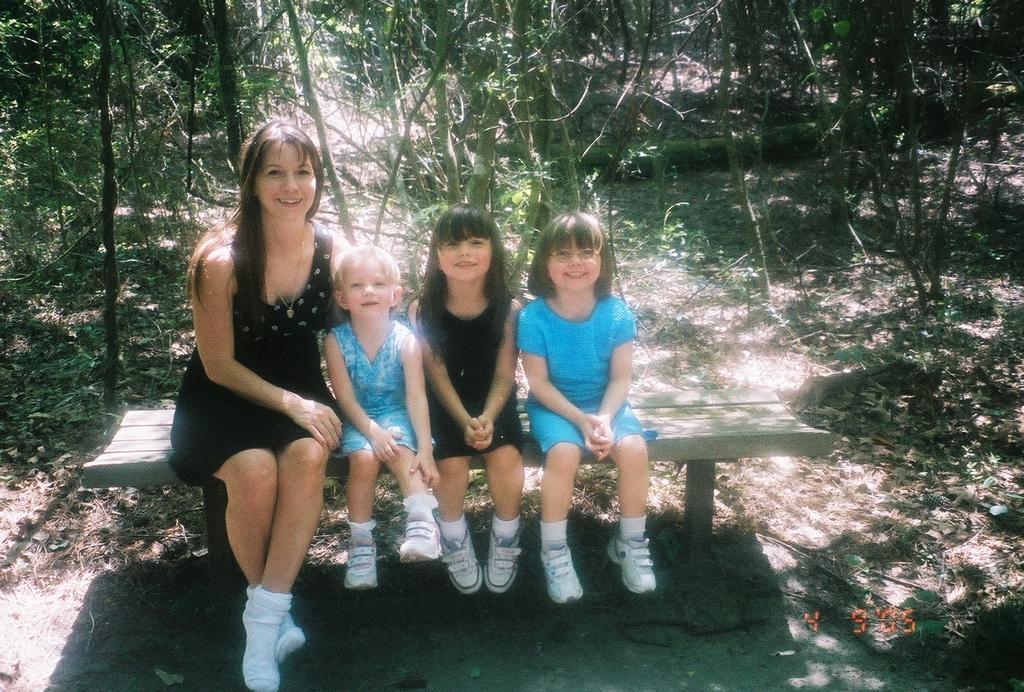Describe this image in one or two sentences. In this image I can see a bench in the front and on it I can see a woman and three girls are sitting. I can also see two of them are wearing black colour dress and two of them blue. I can also see except one all of them are wearing white colour shoes. In the background I can see number of trees and on the bottom right side of this image I can see a watermark. 